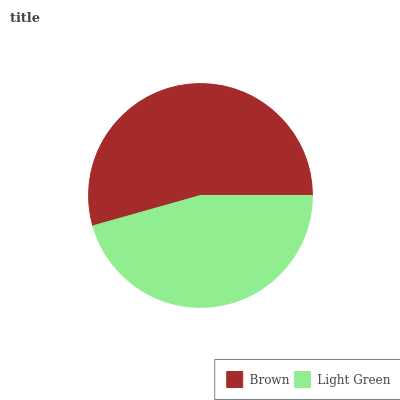Is Light Green the minimum?
Answer yes or no. Yes. Is Brown the maximum?
Answer yes or no. Yes. Is Light Green the maximum?
Answer yes or no. No. Is Brown greater than Light Green?
Answer yes or no. Yes. Is Light Green less than Brown?
Answer yes or no. Yes. Is Light Green greater than Brown?
Answer yes or no. No. Is Brown less than Light Green?
Answer yes or no. No. Is Brown the high median?
Answer yes or no. Yes. Is Light Green the low median?
Answer yes or no. Yes. Is Light Green the high median?
Answer yes or no. No. Is Brown the low median?
Answer yes or no. No. 